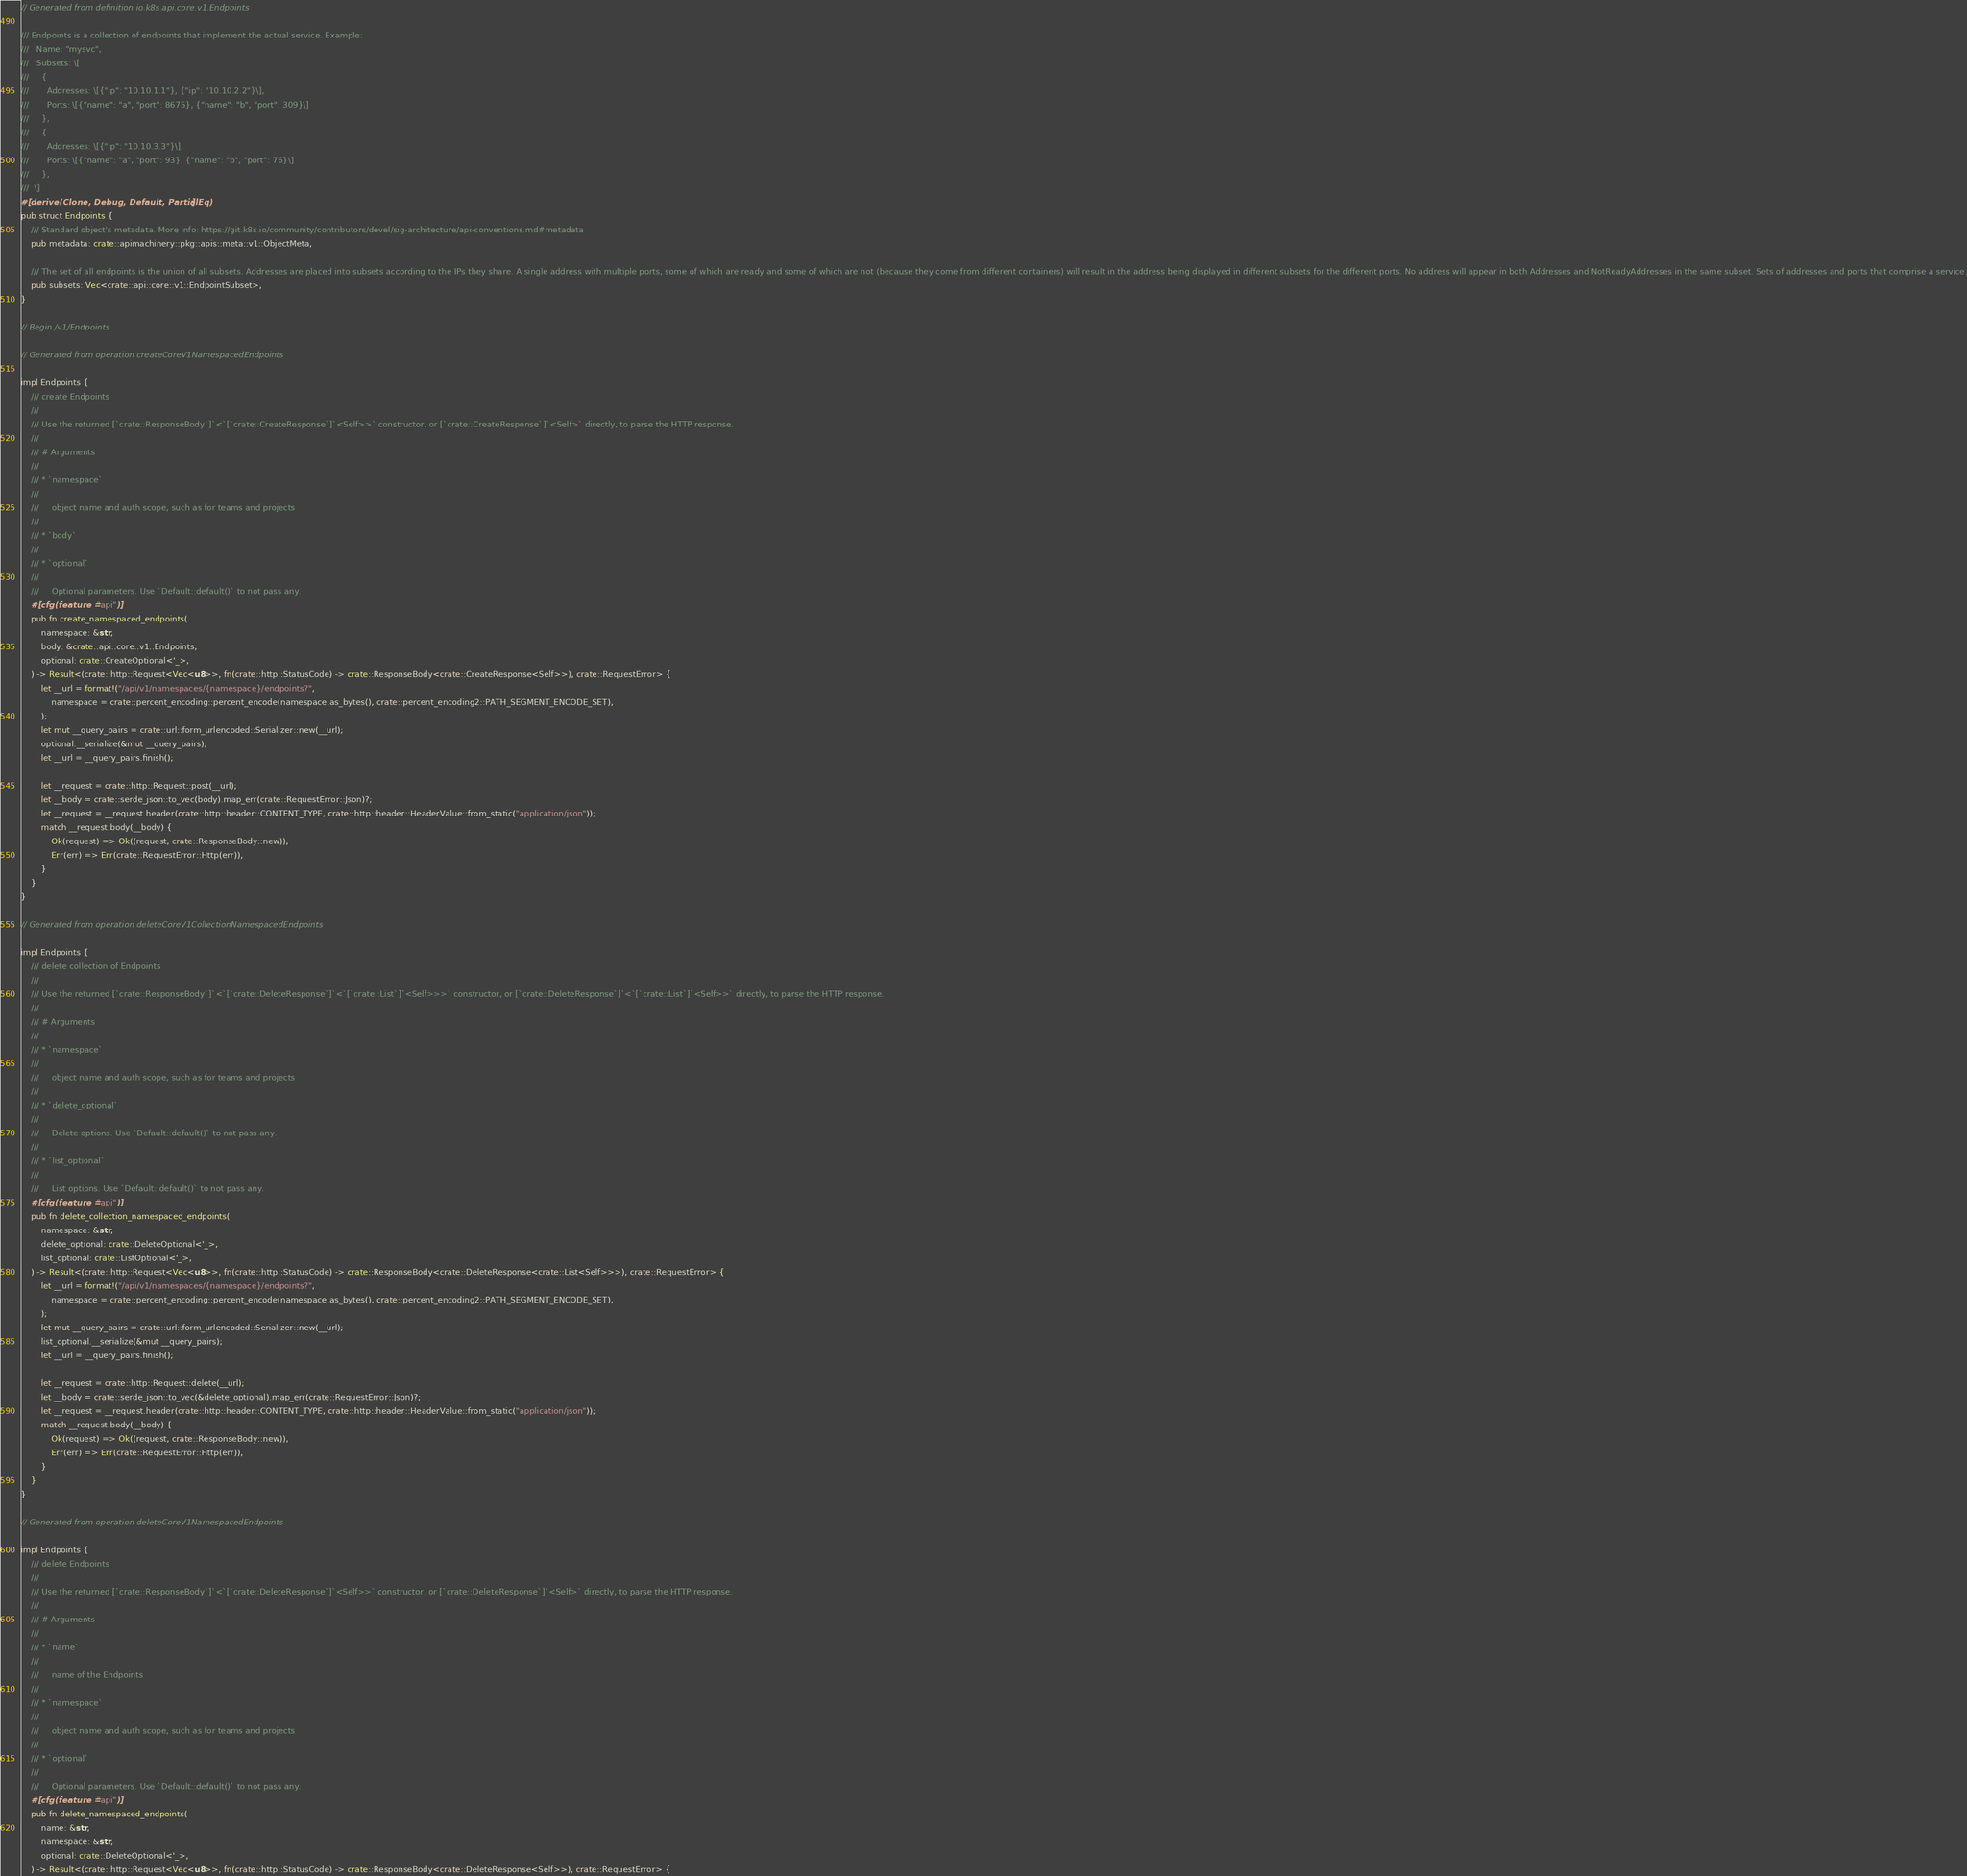<code> <loc_0><loc_0><loc_500><loc_500><_Rust_>// Generated from definition io.k8s.api.core.v1.Endpoints

/// Endpoints is a collection of endpoints that implement the actual service. Example:
///   Name: "mysvc",
///   Subsets: \[
///     {
///       Addresses: \[{"ip": "10.10.1.1"}, {"ip": "10.10.2.2"}\],
///       Ports: \[{"name": "a", "port": 8675}, {"name": "b", "port": 309}\]
///     },
///     {
///       Addresses: \[{"ip": "10.10.3.3"}\],
///       Ports: \[{"name": "a", "port": 93}, {"name": "b", "port": 76}\]
///     },
///  \]
#[derive(Clone, Debug, Default, PartialEq)]
pub struct Endpoints {
    /// Standard object's metadata. More info: https://git.k8s.io/community/contributors/devel/sig-architecture/api-conventions.md#metadata
    pub metadata: crate::apimachinery::pkg::apis::meta::v1::ObjectMeta,

    /// The set of all endpoints is the union of all subsets. Addresses are placed into subsets according to the IPs they share. A single address with multiple ports, some of which are ready and some of which are not (because they come from different containers) will result in the address being displayed in different subsets for the different ports. No address will appear in both Addresses and NotReadyAddresses in the same subset. Sets of addresses and ports that comprise a service.
    pub subsets: Vec<crate::api::core::v1::EndpointSubset>,
}

// Begin /v1/Endpoints

// Generated from operation createCoreV1NamespacedEndpoints

impl Endpoints {
    /// create Endpoints
    ///
    /// Use the returned [`crate::ResponseBody`]`<`[`crate::CreateResponse`]`<Self>>` constructor, or [`crate::CreateResponse`]`<Self>` directly, to parse the HTTP response.
    ///
    /// # Arguments
    ///
    /// * `namespace`
    ///
    ///     object name and auth scope, such as for teams and projects
    ///
    /// * `body`
    ///
    /// * `optional`
    ///
    ///     Optional parameters. Use `Default::default()` to not pass any.
    #[cfg(feature = "api")]
    pub fn create_namespaced_endpoints(
        namespace: &str,
        body: &crate::api::core::v1::Endpoints,
        optional: crate::CreateOptional<'_>,
    ) -> Result<(crate::http::Request<Vec<u8>>, fn(crate::http::StatusCode) -> crate::ResponseBody<crate::CreateResponse<Self>>), crate::RequestError> {
        let __url = format!("/api/v1/namespaces/{namespace}/endpoints?",
            namespace = crate::percent_encoding::percent_encode(namespace.as_bytes(), crate::percent_encoding2::PATH_SEGMENT_ENCODE_SET),
        );
        let mut __query_pairs = crate::url::form_urlencoded::Serializer::new(__url);
        optional.__serialize(&mut __query_pairs);
        let __url = __query_pairs.finish();

        let __request = crate::http::Request::post(__url);
        let __body = crate::serde_json::to_vec(body).map_err(crate::RequestError::Json)?;
        let __request = __request.header(crate::http::header::CONTENT_TYPE, crate::http::header::HeaderValue::from_static("application/json"));
        match __request.body(__body) {
            Ok(request) => Ok((request, crate::ResponseBody::new)),
            Err(err) => Err(crate::RequestError::Http(err)),
        }
    }
}

// Generated from operation deleteCoreV1CollectionNamespacedEndpoints

impl Endpoints {
    /// delete collection of Endpoints
    ///
    /// Use the returned [`crate::ResponseBody`]`<`[`crate::DeleteResponse`]`<`[`crate::List`]`<Self>>>` constructor, or [`crate::DeleteResponse`]`<`[`crate::List`]`<Self>>` directly, to parse the HTTP response.
    ///
    /// # Arguments
    ///
    /// * `namespace`
    ///
    ///     object name and auth scope, such as for teams and projects
    ///
    /// * `delete_optional`
    ///
    ///     Delete options. Use `Default::default()` to not pass any.
    ///
    /// * `list_optional`
    ///
    ///     List options. Use `Default::default()` to not pass any.
    #[cfg(feature = "api")]
    pub fn delete_collection_namespaced_endpoints(
        namespace: &str,
        delete_optional: crate::DeleteOptional<'_>,
        list_optional: crate::ListOptional<'_>,
    ) -> Result<(crate::http::Request<Vec<u8>>, fn(crate::http::StatusCode) -> crate::ResponseBody<crate::DeleteResponse<crate::List<Self>>>), crate::RequestError> {
        let __url = format!("/api/v1/namespaces/{namespace}/endpoints?",
            namespace = crate::percent_encoding::percent_encode(namespace.as_bytes(), crate::percent_encoding2::PATH_SEGMENT_ENCODE_SET),
        );
        let mut __query_pairs = crate::url::form_urlencoded::Serializer::new(__url);
        list_optional.__serialize(&mut __query_pairs);
        let __url = __query_pairs.finish();

        let __request = crate::http::Request::delete(__url);
        let __body = crate::serde_json::to_vec(&delete_optional).map_err(crate::RequestError::Json)?;
        let __request = __request.header(crate::http::header::CONTENT_TYPE, crate::http::header::HeaderValue::from_static("application/json"));
        match __request.body(__body) {
            Ok(request) => Ok((request, crate::ResponseBody::new)),
            Err(err) => Err(crate::RequestError::Http(err)),
        }
    }
}

// Generated from operation deleteCoreV1NamespacedEndpoints

impl Endpoints {
    /// delete Endpoints
    ///
    /// Use the returned [`crate::ResponseBody`]`<`[`crate::DeleteResponse`]`<Self>>` constructor, or [`crate::DeleteResponse`]`<Self>` directly, to parse the HTTP response.
    ///
    /// # Arguments
    ///
    /// * `name`
    ///
    ///     name of the Endpoints
    ///
    /// * `namespace`
    ///
    ///     object name and auth scope, such as for teams and projects
    ///
    /// * `optional`
    ///
    ///     Optional parameters. Use `Default::default()` to not pass any.
    #[cfg(feature = "api")]
    pub fn delete_namespaced_endpoints(
        name: &str,
        namespace: &str,
        optional: crate::DeleteOptional<'_>,
    ) -> Result<(crate::http::Request<Vec<u8>>, fn(crate::http::StatusCode) -> crate::ResponseBody<crate::DeleteResponse<Self>>), crate::RequestError> {</code> 